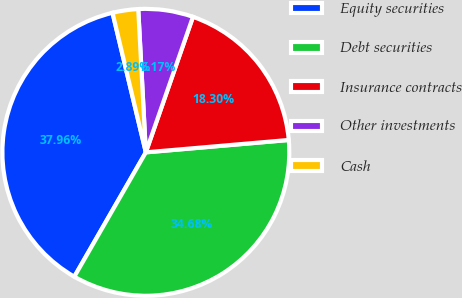<chart> <loc_0><loc_0><loc_500><loc_500><pie_chart><fcel>Equity securities<fcel>Debt securities<fcel>Insurance contracts<fcel>Other investments<fcel>Cash<nl><fcel>37.96%<fcel>34.68%<fcel>18.3%<fcel>6.17%<fcel>2.89%<nl></chart> 